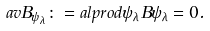Convert formula to latex. <formula><loc_0><loc_0><loc_500><loc_500>\ a v { B } _ { \psi _ { \lambda } } \colon = a l p r o d { \psi _ { \lambda } } { B \psi _ { \lambda } } = 0 .</formula> 